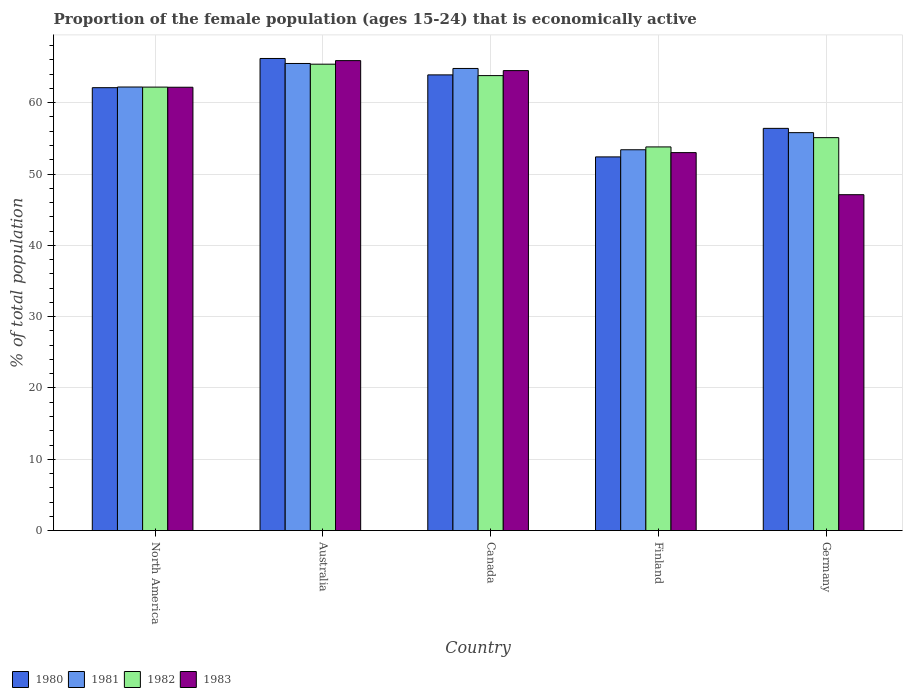How many different coloured bars are there?
Keep it short and to the point. 4. Are the number of bars per tick equal to the number of legend labels?
Keep it short and to the point. Yes. How many bars are there on the 4th tick from the right?
Keep it short and to the point. 4. What is the label of the 2nd group of bars from the left?
Make the answer very short. Australia. What is the proportion of the female population that is economically active in 1981 in Germany?
Offer a very short reply. 55.8. Across all countries, what is the maximum proportion of the female population that is economically active in 1983?
Give a very brief answer. 65.9. Across all countries, what is the minimum proportion of the female population that is economically active in 1980?
Offer a very short reply. 52.4. What is the total proportion of the female population that is economically active in 1982 in the graph?
Offer a very short reply. 300.29. What is the difference between the proportion of the female population that is economically active in 1981 in Germany and that in North America?
Give a very brief answer. -6.4. What is the difference between the proportion of the female population that is economically active in 1980 in North America and the proportion of the female population that is economically active in 1981 in Germany?
Provide a succinct answer. 6.31. What is the average proportion of the female population that is economically active in 1982 per country?
Your answer should be very brief. 60.06. What is the difference between the proportion of the female population that is economically active of/in 1983 and proportion of the female population that is economically active of/in 1982 in North America?
Provide a short and direct response. -0.02. In how many countries, is the proportion of the female population that is economically active in 1980 greater than 34 %?
Provide a succinct answer. 5. What is the ratio of the proportion of the female population that is economically active in 1983 in Finland to that in Germany?
Provide a succinct answer. 1.13. Is the proportion of the female population that is economically active in 1980 in Finland less than that in Germany?
Your response must be concise. Yes. Is the difference between the proportion of the female population that is economically active in 1983 in Canada and Germany greater than the difference between the proportion of the female population that is economically active in 1982 in Canada and Germany?
Your response must be concise. Yes. What is the difference between the highest and the second highest proportion of the female population that is economically active in 1982?
Offer a very short reply. 3.21. What is the difference between the highest and the lowest proportion of the female population that is economically active in 1981?
Provide a succinct answer. 12.1. In how many countries, is the proportion of the female population that is economically active in 1982 greater than the average proportion of the female population that is economically active in 1982 taken over all countries?
Give a very brief answer. 3. Is it the case that in every country, the sum of the proportion of the female population that is economically active in 1982 and proportion of the female population that is economically active in 1983 is greater than the sum of proportion of the female population that is economically active in 1981 and proportion of the female population that is economically active in 1980?
Keep it short and to the point. No. What does the 2nd bar from the left in Finland represents?
Provide a succinct answer. 1981. Is it the case that in every country, the sum of the proportion of the female population that is economically active in 1982 and proportion of the female population that is economically active in 1983 is greater than the proportion of the female population that is economically active in 1981?
Provide a succinct answer. Yes. Are all the bars in the graph horizontal?
Make the answer very short. No. What is the difference between two consecutive major ticks on the Y-axis?
Provide a succinct answer. 10. Are the values on the major ticks of Y-axis written in scientific E-notation?
Your response must be concise. No. Does the graph contain any zero values?
Your answer should be very brief. No. How many legend labels are there?
Your answer should be very brief. 4. What is the title of the graph?
Give a very brief answer. Proportion of the female population (ages 15-24) that is economically active. Does "1978" appear as one of the legend labels in the graph?
Keep it short and to the point. No. What is the label or title of the Y-axis?
Your answer should be compact. % of total population. What is the % of total population in 1980 in North America?
Give a very brief answer. 62.11. What is the % of total population of 1981 in North America?
Keep it short and to the point. 62.2. What is the % of total population in 1982 in North America?
Provide a succinct answer. 62.19. What is the % of total population in 1983 in North America?
Keep it short and to the point. 62.17. What is the % of total population in 1980 in Australia?
Ensure brevity in your answer.  66.2. What is the % of total population in 1981 in Australia?
Provide a short and direct response. 65.5. What is the % of total population of 1982 in Australia?
Keep it short and to the point. 65.4. What is the % of total population in 1983 in Australia?
Your answer should be very brief. 65.9. What is the % of total population of 1980 in Canada?
Offer a terse response. 63.9. What is the % of total population in 1981 in Canada?
Your answer should be compact. 64.8. What is the % of total population of 1982 in Canada?
Your answer should be compact. 63.8. What is the % of total population of 1983 in Canada?
Give a very brief answer. 64.5. What is the % of total population in 1980 in Finland?
Provide a short and direct response. 52.4. What is the % of total population of 1981 in Finland?
Provide a succinct answer. 53.4. What is the % of total population of 1982 in Finland?
Your response must be concise. 53.8. What is the % of total population of 1983 in Finland?
Provide a succinct answer. 53. What is the % of total population in 1980 in Germany?
Your answer should be compact. 56.4. What is the % of total population of 1981 in Germany?
Keep it short and to the point. 55.8. What is the % of total population of 1982 in Germany?
Your response must be concise. 55.1. What is the % of total population in 1983 in Germany?
Provide a succinct answer. 47.1. Across all countries, what is the maximum % of total population of 1980?
Provide a short and direct response. 66.2. Across all countries, what is the maximum % of total population of 1981?
Provide a short and direct response. 65.5. Across all countries, what is the maximum % of total population of 1982?
Your answer should be very brief. 65.4. Across all countries, what is the maximum % of total population of 1983?
Your answer should be very brief. 65.9. Across all countries, what is the minimum % of total population of 1980?
Ensure brevity in your answer.  52.4. Across all countries, what is the minimum % of total population of 1981?
Make the answer very short. 53.4. Across all countries, what is the minimum % of total population of 1982?
Offer a very short reply. 53.8. Across all countries, what is the minimum % of total population in 1983?
Provide a succinct answer. 47.1. What is the total % of total population in 1980 in the graph?
Make the answer very short. 301.01. What is the total % of total population in 1981 in the graph?
Make the answer very short. 301.7. What is the total % of total population of 1982 in the graph?
Your answer should be very brief. 300.29. What is the total % of total population in 1983 in the graph?
Provide a short and direct response. 292.67. What is the difference between the % of total population in 1980 in North America and that in Australia?
Your answer should be very brief. -4.09. What is the difference between the % of total population in 1981 in North America and that in Australia?
Provide a succinct answer. -3.3. What is the difference between the % of total population of 1982 in North America and that in Australia?
Ensure brevity in your answer.  -3.21. What is the difference between the % of total population in 1983 in North America and that in Australia?
Your answer should be very brief. -3.73. What is the difference between the % of total population in 1980 in North America and that in Canada?
Ensure brevity in your answer.  -1.79. What is the difference between the % of total population in 1981 in North America and that in Canada?
Offer a very short reply. -2.6. What is the difference between the % of total population of 1982 in North America and that in Canada?
Offer a very short reply. -1.61. What is the difference between the % of total population in 1983 in North America and that in Canada?
Provide a short and direct response. -2.33. What is the difference between the % of total population of 1980 in North America and that in Finland?
Your answer should be very brief. 9.71. What is the difference between the % of total population in 1981 in North America and that in Finland?
Offer a very short reply. 8.8. What is the difference between the % of total population of 1982 in North America and that in Finland?
Provide a short and direct response. 8.39. What is the difference between the % of total population of 1983 in North America and that in Finland?
Your response must be concise. 9.17. What is the difference between the % of total population in 1980 in North America and that in Germany?
Your answer should be very brief. 5.71. What is the difference between the % of total population of 1981 in North America and that in Germany?
Your response must be concise. 6.4. What is the difference between the % of total population of 1982 in North America and that in Germany?
Your answer should be very brief. 7.09. What is the difference between the % of total population of 1983 in North America and that in Germany?
Your answer should be compact. 15.07. What is the difference between the % of total population in 1980 in Australia and that in Canada?
Keep it short and to the point. 2.3. What is the difference between the % of total population in 1981 in Australia and that in Canada?
Give a very brief answer. 0.7. What is the difference between the % of total population in 1982 in Australia and that in Canada?
Ensure brevity in your answer.  1.6. What is the difference between the % of total population of 1983 in Australia and that in Canada?
Make the answer very short. 1.4. What is the difference between the % of total population in 1980 in Australia and that in Germany?
Offer a terse response. 9.8. What is the difference between the % of total population in 1981 in Australia and that in Germany?
Provide a succinct answer. 9.7. What is the difference between the % of total population of 1983 in Australia and that in Germany?
Offer a very short reply. 18.8. What is the difference between the % of total population of 1982 in Canada and that in Finland?
Give a very brief answer. 10. What is the difference between the % of total population of 1981 in Canada and that in Germany?
Ensure brevity in your answer.  9. What is the difference between the % of total population of 1980 in Finland and that in Germany?
Give a very brief answer. -4. What is the difference between the % of total population of 1983 in Finland and that in Germany?
Offer a very short reply. 5.9. What is the difference between the % of total population of 1980 in North America and the % of total population of 1981 in Australia?
Ensure brevity in your answer.  -3.39. What is the difference between the % of total population in 1980 in North America and the % of total population in 1982 in Australia?
Give a very brief answer. -3.29. What is the difference between the % of total population of 1980 in North America and the % of total population of 1983 in Australia?
Ensure brevity in your answer.  -3.79. What is the difference between the % of total population in 1981 in North America and the % of total population in 1982 in Australia?
Provide a succinct answer. -3.2. What is the difference between the % of total population in 1981 in North America and the % of total population in 1983 in Australia?
Ensure brevity in your answer.  -3.7. What is the difference between the % of total population of 1982 in North America and the % of total population of 1983 in Australia?
Provide a short and direct response. -3.71. What is the difference between the % of total population in 1980 in North America and the % of total population in 1981 in Canada?
Provide a succinct answer. -2.69. What is the difference between the % of total population of 1980 in North America and the % of total population of 1982 in Canada?
Keep it short and to the point. -1.69. What is the difference between the % of total population of 1980 in North America and the % of total population of 1983 in Canada?
Ensure brevity in your answer.  -2.39. What is the difference between the % of total population of 1981 in North America and the % of total population of 1982 in Canada?
Your answer should be very brief. -1.6. What is the difference between the % of total population of 1981 in North America and the % of total population of 1983 in Canada?
Ensure brevity in your answer.  -2.3. What is the difference between the % of total population of 1982 in North America and the % of total population of 1983 in Canada?
Offer a very short reply. -2.31. What is the difference between the % of total population of 1980 in North America and the % of total population of 1981 in Finland?
Give a very brief answer. 8.71. What is the difference between the % of total population of 1980 in North America and the % of total population of 1982 in Finland?
Your answer should be compact. 8.31. What is the difference between the % of total population of 1980 in North America and the % of total population of 1983 in Finland?
Offer a very short reply. 9.11. What is the difference between the % of total population in 1981 in North America and the % of total population in 1982 in Finland?
Ensure brevity in your answer.  8.4. What is the difference between the % of total population of 1981 in North America and the % of total population of 1983 in Finland?
Make the answer very short. 9.2. What is the difference between the % of total population of 1982 in North America and the % of total population of 1983 in Finland?
Offer a very short reply. 9.19. What is the difference between the % of total population in 1980 in North America and the % of total population in 1981 in Germany?
Keep it short and to the point. 6.31. What is the difference between the % of total population in 1980 in North America and the % of total population in 1982 in Germany?
Your answer should be compact. 7.01. What is the difference between the % of total population in 1980 in North America and the % of total population in 1983 in Germany?
Offer a very short reply. 15.01. What is the difference between the % of total population of 1981 in North America and the % of total population of 1982 in Germany?
Make the answer very short. 7.1. What is the difference between the % of total population of 1981 in North America and the % of total population of 1983 in Germany?
Keep it short and to the point. 15.1. What is the difference between the % of total population in 1982 in North America and the % of total population in 1983 in Germany?
Your answer should be very brief. 15.09. What is the difference between the % of total population in 1980 in Australia and the % of total population in 1981 in Canada?
Your answer should be very brief. 1.4. What is the difference between the % of total population in 1980 in Australia and the % of total population in 1982 in Canada?
Offer a very short reply. 2.4. What is the difference between the % of total population in 1980 in Australia and the % of total population in 1983 in Canada?
Provide a short and direct response. 1.7. What is the difference between the % of total population of 1982 in Australia and the % of total population of 1983 in Canada?
Make the answer very short. 0.9. What is the difference between the % of total population in 1981 in Australia and the % of total population in 1982 in Finland?
Ensure brevity in your answer.  11.7. What is the difference between the % of total population of 1981 in Australia and the % of total population of 1983 in Finland?
Provide a short and direct response. 12.5. What is the difference between the % of total population of 1982 in Australia and the % of total population of 1983 in Finland?
Your answer should be compact. 12.4. What is the difference between the % of total population of 1980 in Australia and the % of total population of 1982 in Germany?
Offer a terse response. 11.1. What is the difference between the % of total population of 1980 in Australia and the % of total population of 1983 in Germany?
Keep it short and to the point. 19.1. What is the difference between the % of total population of 1982 in Australia and the % of total population of 1983 in Germany?
Your response must be concise. 18.3. What is the difference between the % of total population in 1980 in Canada and the % of total population in 1983 in Finland?
Your response must be concise. 10.9. What is the difference between the % of total population of 1981 in Canada and the % of total population of 1983 in Finland?
Offer a terse response. 11.8. What is the difference between the % of total population in 1982 in Canada and the % of total population in 1983 in Finland?
Your answer should be very brief. 10.8. What is the difference between the % of total population in 1981 in Canada and the % of total population in 1982 in Germany?
Keep it short and to the point. 9.7. What is the difference between the % of total population in 1982 in Canada and the % of total population in 1983 in Germany?
Offer a terse response. 16.7. What is the difference between the % of total population of 1980 in Finland and the % of total population of 1981 in Germany?
Your response must be concise. -3.4. What is the difference between the % of total population in 1980 in Finland and the % of total population in 1982 in Germany?
Provide a succinct answer. -2.7. What is the difference between the % of total population of 1981 in Finland and the % of total population of 1982 in Germany?
Offer a very short reply. -1.7. What is the difference between the % of total population in 1982 in Finland and the % of total population in 1983 in Germany?
Give a very brief answer. 6.7. What is the average % of total population of 1980 per country?
Offer a very short reply. 60.2. What is the average % of total population of 1981 per country?
Provide a short and direct response. 60.34. What is the average % of total population of 1982 per country?
Keep it short and to the point. 60.06. What is the average % of total population of 1983 per country?
Provide a succinct answer. 58.53. What is the difference between the % of total population in 1980 and % of total population in 1981 in North America?
Keep it short and to the point. -0.09. What is the difference between the % of total population in 1980 and % of total population in 1982 in North America?
Make the answer very short. -0.08. What is the difference between the % of total population in 1980 and % of total population in 1983 in North America?
Offer a very short reply. -0.06. What is the difference between the % of total population in 1981 and % of total population in 1982 in North America?
Make the answer very short. 0.01. What is the difference between the % of total population of 1981 and % of total population of 1983 in North America?
Your answer should be compact. 0.03. What is the difference between the % of total population of 1982 and % of total population of 1983 in North America?
Your answer should be very brief. 0.02. What is the difference between the % of total population in 1980 and % of total population in 1981 in Australia?
Your answer should be very brief. 0.7. What is the difference between the % of total population of 1980 and % of total population of 1982 in Australia?
Your response must be concise. 0.8. What is the difference between the % of total population in 1981 and % of total population in 1982 in Australia?
Your answer should be compact. 0.1. What is the difference between the % of total population in 1981 and % of total population in 1983 in Australia?
Your answer should be compact. -0.4. What is the difference between the % of total population of 1980 and % of total population of 1981 in Canada?
Your response must be concise. -0.9. What is the difference between the % of total population in 1980 and % of total population in 1982 in Canada?
Keep it short and to the point. 0.1. What is the difference between the % of total population of 1980 and % of total population of 1983 in Canada?
Make the answer very short. -0.6. What is the difference between the % of total population of 1981 and % of total population of 1983 in Canada?
Provide a short and direct response. 0.3. What is the difference between the % of total population in 1980 and % of total population in 1982 in Finland?
Offer a very short reply. -1.4. What is the difference between the % of total population in 1981 and % of total population in 1983 in Finland?
Your answer should be compact. 0.4. What is the difference between the % of total population of 1982 and % of total population of 1983 in Finland?
Make the answer very short. 0.8. What is the difference between the % of total population in 1980 and % of total population in 1982 in Germany?
Give a very brief answer. 1.3. What is the difference between the % of total population of 1980 and % of total population of 1983 in Germany?
Make the answer very short. 9.3. What is the difference between the % of total population of 1981 and % of total population of 1983 in Germany?
Give a very brief answer. 8.7. What is the ratio of the % of total population in 1980 in North America to that in Australia?
Ensure brevity in your answer.  0.94. What is the ratio of the % of total population of 1981 in North America to that in Australia?
Your response must be concise. 0.95. What is the ratio of the % of total population of 1982 in North America to that in Australia?
Make the answer very short. 0.95. What is the ratio of the % of total population in 1983 in North America to that in Australia?
Provide a short and direct response. 0.94. What is the ratio of the % of total population in 1980 in North America to that in Canada?
Provide a short and direct response. 0.97. What is the ratio of the % of total population in 1981 in North America to that in Canada?
Your answer should be compact. 0.96. What is the ratio of the % of total population in 1982 in North America to that in Canada?
Offer a very short reply. 0.97. What is the ratio of the % of total population of 1983 in North America to that in Canada?
Keep it short and to the point. 0.96. What is the ratio of the % of total population of 1980 in North America to that in Finland?
Your answer should be compact. 1.19. What is the ratio of the % of total population of 1981 in North America to that in Finland?
Ensure brevity in your answer.  1.16. What is the ratio of the % of total population of 1982 in North America to that in Finland?
Your response must be concise. 1.16. What is the ratio of the % of total population in 1983 in North America to that in Finland?
Make the answer very short. 1.17. What is the ratio of the % of total population in 1980 in North America to that in Germany?
Keep it short and to the point. 1.1. What is the ratio of the % of total population of 1981 in North America to that in Germany?
Your answer should be very brief. 1.11. What is the ratio of the % of total population in 1982 in North America to that in Germany?
Offer a terse response. 1.13. What is the ratio of the % of total population in 1983 in North America to that in Germany?
Keep it short and to the point. 1.32. What is the ratio of the % of total population of 1980 in Australia to that in Canada?
Your response must be concise. 1.04. What is the ratio of the % of total population in 1981 in Australia to that in Canada?
Your answer should be very brief. 1.01. What is the ratio of the % of total population of 1982 in Australia to that in Canada?
Give a very brief answer. 1.03. What is the ratio of the % of total population of 1983 in Australia to that in Canada?
Offer a very short reply. 1.02. What is the ratio of the % of total population of 1980 in Australia to that in Finland?
Offer a terse response. 1.26. What is the ratio of the % of total population of 1981 in Australia to that in Finland?
Ensure brevity in your answer.  1.23. What is the ratio of the % of total population of 1982 in Australia to that in Finland?
Make the answer very short. 1.22. What is the ratio of the % of total population of 1983 in Australia to that in Finland?
Offer a very short reply. 1.24. What is the ratio of the % of total population in 1980 in Australia to that in Germany?
Offer a terse response. 1.17. What is the ratio of the % of total population of 1981 in Australia to that in Germany?
Your answer should be compact. 1.17. What is the ratio of the % of total population in 1982 in Australia to that in Germany?
Give a very brief answer. 1.19. What is the ratio of the % of total population in 1983 in Australia to that in Germany?
Offer a terse response. 1.4. What is the ratio of the % of total population in 1980 in Canada to that in Finland?
Provide a succinct answer. 1.22. What is the ratio of the % of total population in 1981 in Canada to that in Finland?
Your answer should be compact. 1.21. What is the ratio of the % of total population of 1982 in Canada to that in Finland?
Your answer should be very brief. 1.19. What is the ratio of the % of total population in 1983 in Canada to that in Finland?
Provide a short and direct response. 1.22. What is the ratio of the % of total population of 1980 in Canada to that in Germany?
Give a very brief answer. 1.13. What is the ratio of the % of total population of 1981 in Canada to that in Germany?
Provide a short and direct response. 1.16. What is the ratio of the % of total population in 1982 in Canada to that in Germany?
Your answer should be very brief. 1.16. What is the ratio of the % of total population of 1983 in Canada to that in Germany?
Give a very brief answer. 1.37. What is the ratio of the % of total population in 1980 in Finland to that in Germany?
Provide a succinct answer. 0.93. What is the ratio of the % of total population of 1982 in Finland to that in Germany?
Offer a terse response. 0.98. What is the ratio of the % of total population of 1983 in Finland to that in Germany?
Provide a succinct answer. 1.13. What is the difference between the highest and the second highest % of total population of 1980?
Provide a short and direct response. 2.3. What is the difference between the highest and the lowest % of total population of 1981?
Provide a succinct answer. 12.1. 